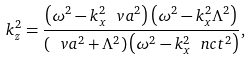<formula> <loc_0><loc_0><loc_500><loc_500>k _ { z } ^ { 2 } = \frac { \left ( \omega ^ { 2 } - k _ { x } ^ { 2 } \ v a ^ { 2 } \right ) \left ( \omega ^ { 2 } - k _ { x } ^ { 2 } \Lambda ^ { 2 } \right ) } { \left ( \ v a ^ { 2 } + \Lambda ^ { 2 } \right ) \left ( \omega ^ { 2 } - k _ { x } ^ { 2 } \ n c t ^ { 2 } \right ) } ,</formula> 